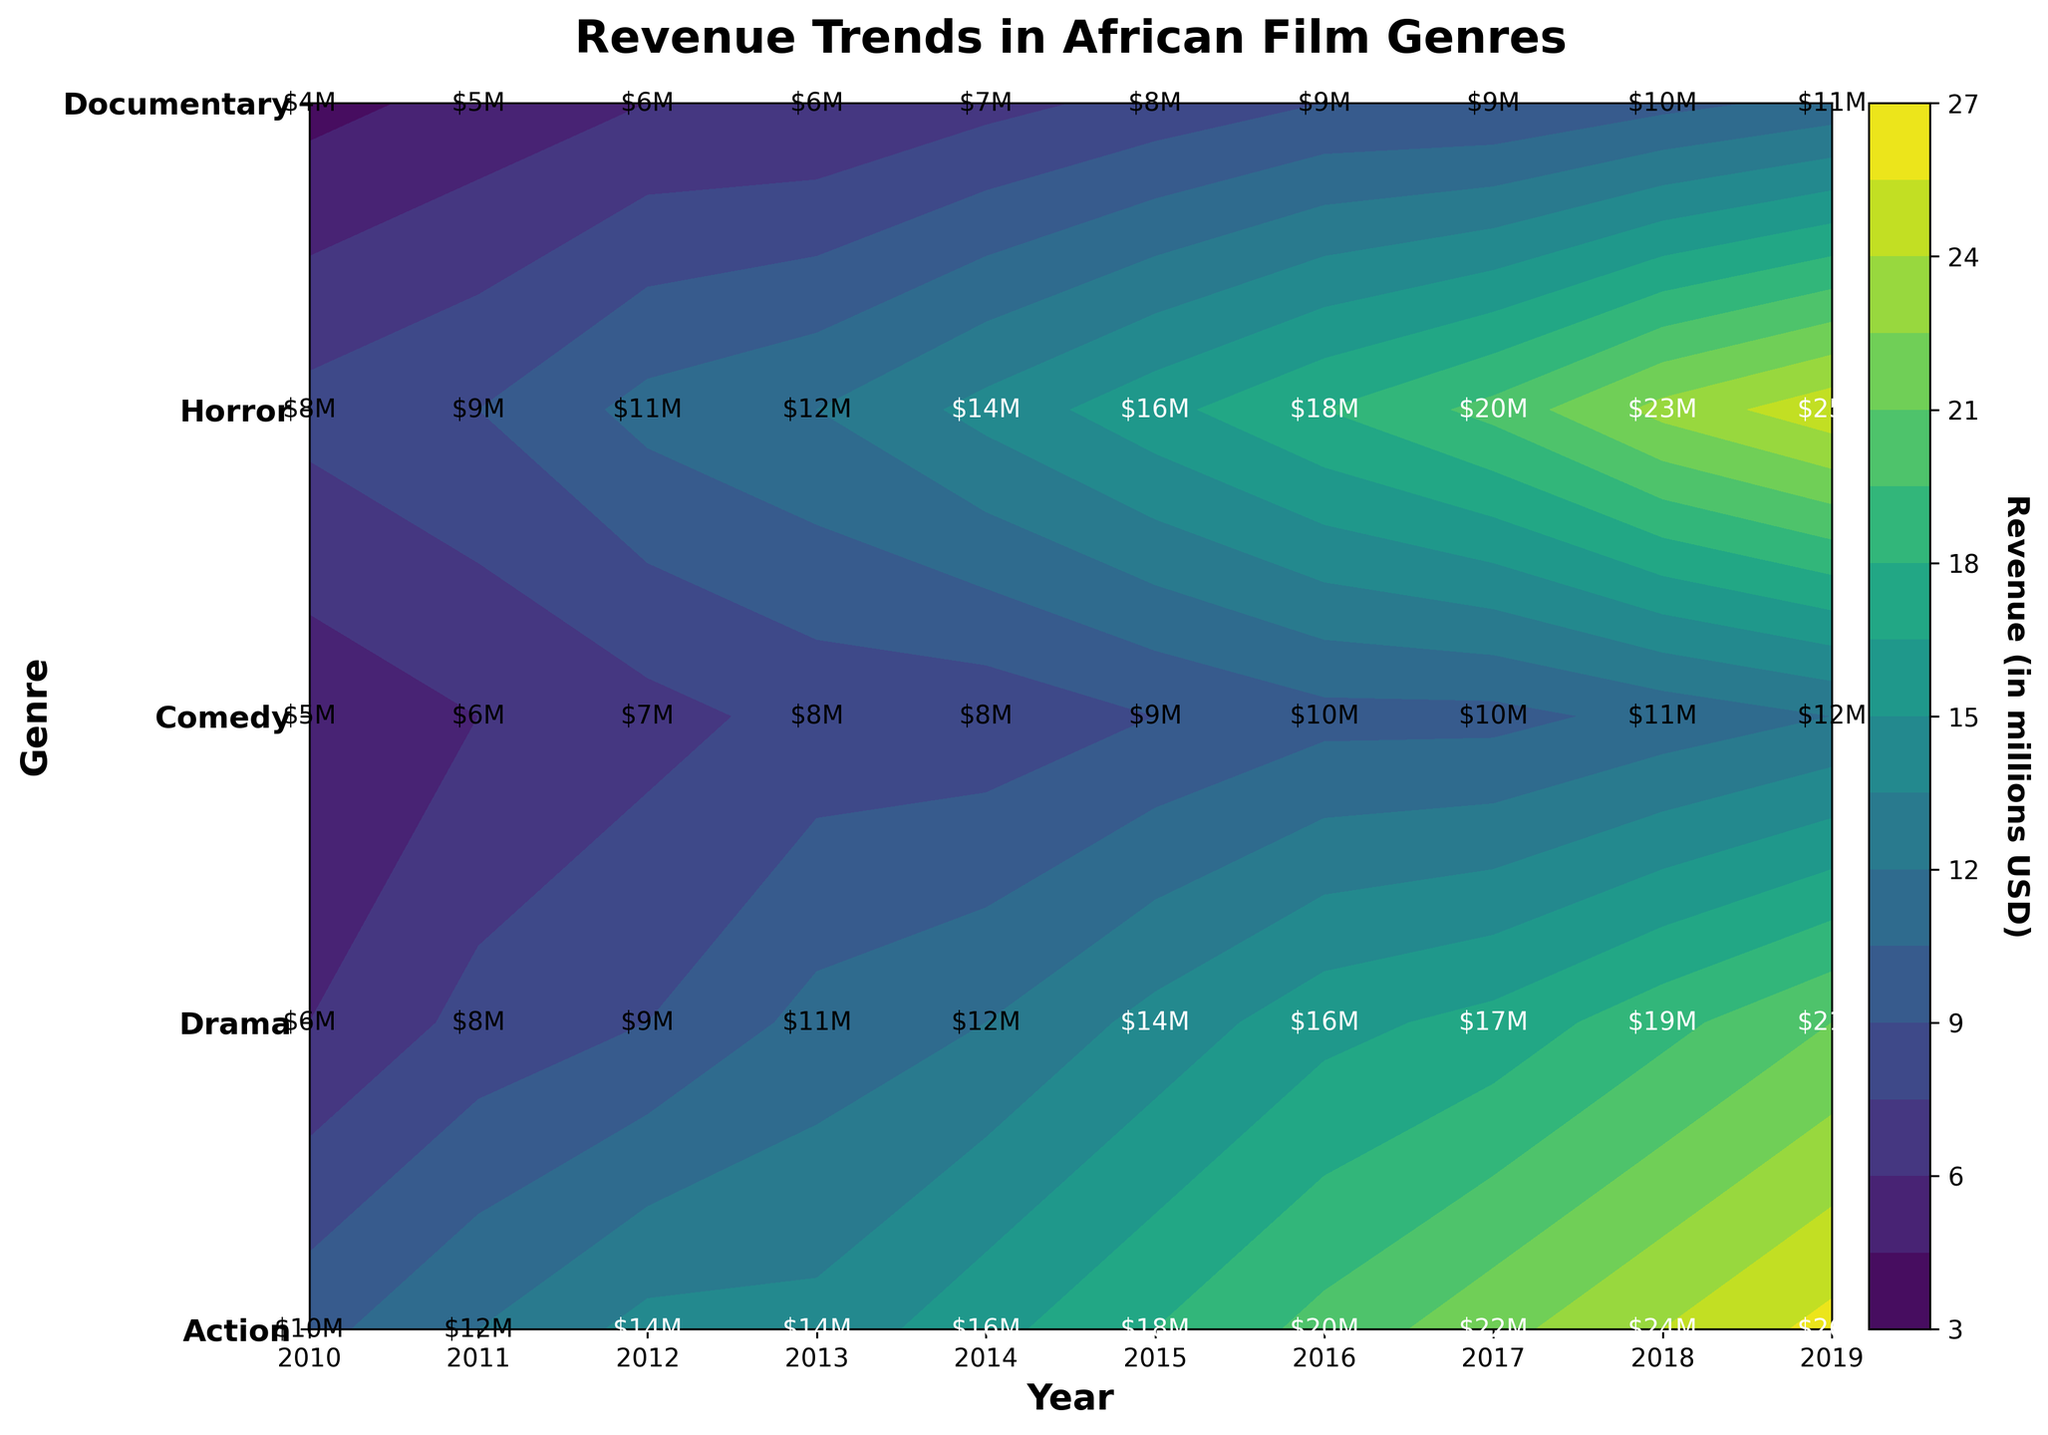What is the title of the plot? The title of the plot is displayed prominently at the top of the figure.
Answer: Revenue Trends in African Film Genres Which genre has the highest revenue in 2019? By looking at the text annotations in the 2019 column, identify the highest revenue figure and the corresponding genre.
Answer: Action What is the color of the highest revenue region on the contour plot? The highest revenue regions appear in the color indicated by the peak value in the colorbar legend, at the maximum level.
Answer: A shade of bright yellow or light green (depending on the colorbar range) How does the revenue of Comedy in 2012 compare to that in 2019? Look for the Comedy genre row and check the text annotations for the years 2012 and 2019 to compare the values.
Answer: 2012 has $9M and 2019 has $21M Which genres had a consistent increase in revenue every year? Examine the text annotations along each genre’s row from 2010 to 2019 and identify which genres show a year-on-year increase without any decrease.
Answer: Action, Drama, Comedy, Documentary What is the average revenue for the Drama genre over the displayed years? Sum all the revenue figures for the Drama genre and divide by the number of years. For Drama: (8 + 9 + 11 + 12 + 14 + 16 + 18 + 20 + 23 + 25) / 10 = 156 / 10.
Answer: $15.6M Which two genres had the same revenue in any given year? Look for matching text annotations in the same year along the different genres.
Answer: Horror and Documentary in 2017 (both $10M) Compare the revenue trends of Horror and Documentary genres from 2010 to 2019. Which one experienced more fluctuations? Observe the changes in revenue values year by year for both Horror and Documentary genres and see which one has more ups and downs.
Answer: Horror What was the total revenue for all genres combined in 2015? Sum the text annotations for all genres in the year 2015. Action: 18, Drama: 16, Comedy: 14, Horror: 8, Documentary: 9. Total = 18 + 16 + 14 + 8 + 9.
Answer: $65M Identify the genre with the least amount of revenue growth from 2010 to 2019. Calculate the difference between the 2019 and 2010 revenue for each genre and find the genre with the smallest difference.
Answer: Horror 